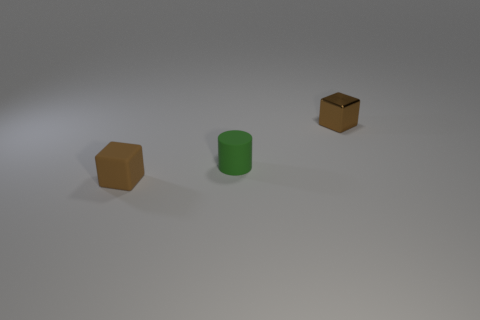Add 1 tiny green objects. How many objects exist? 4 Subtract all blocks. How many objects are left? 1 Add 1 brown rubber cubes. How many brown rubber cubes exist? 2 Subtract 0 cyan balls. How many objects are left? 3 Subtract all small green things. Subtract all green matte things. How many objects are left? 1 Add 1 brown metallic cubes. How many brown metallic cubes are left? 2 